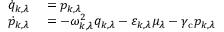Convert formula to latex. <formula><loc_0><loc_0><loc_500><loc_500>\begin{array} { r l } { \dot { q } _ { k , \lambda } } & = p _ { k , \lambda } } \\ { \dot { p } _ { k , \lambda } } & = - \omega _ { k , \lambda } ^ { 2 } q _ { k , \lambda } - \varepsilon _ { k , \lambda } \mu _ { \lambda } - \gamma _ { c } p _ { k , \lambda } } \end{array}</formula> 